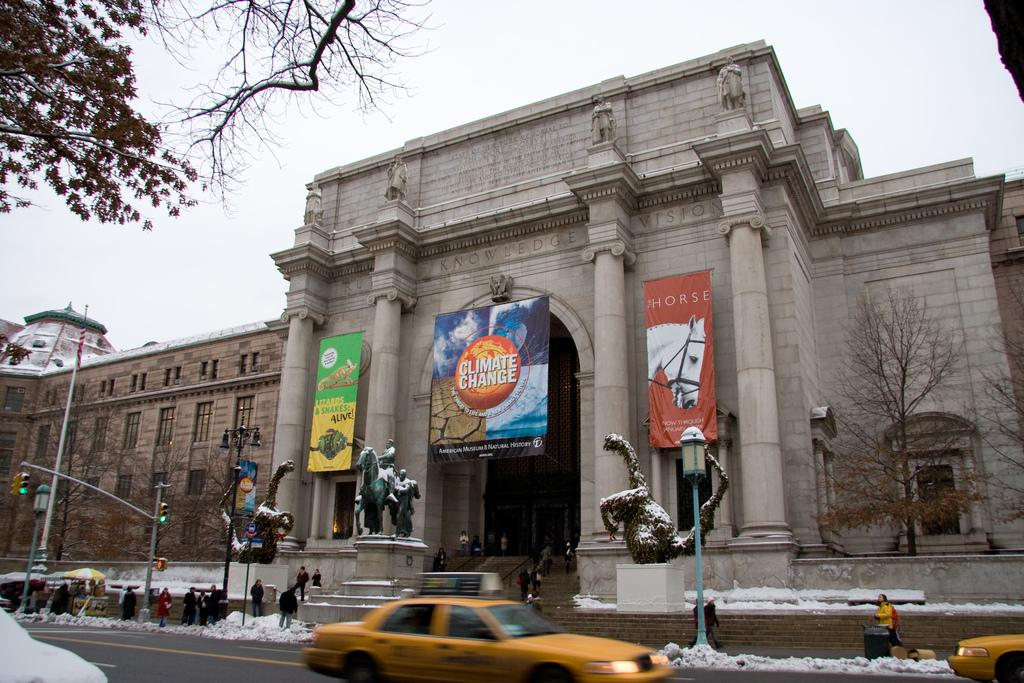<image>
Relay a brief, clear account of the picture shown. a banner of climate change hanging on front of a building 